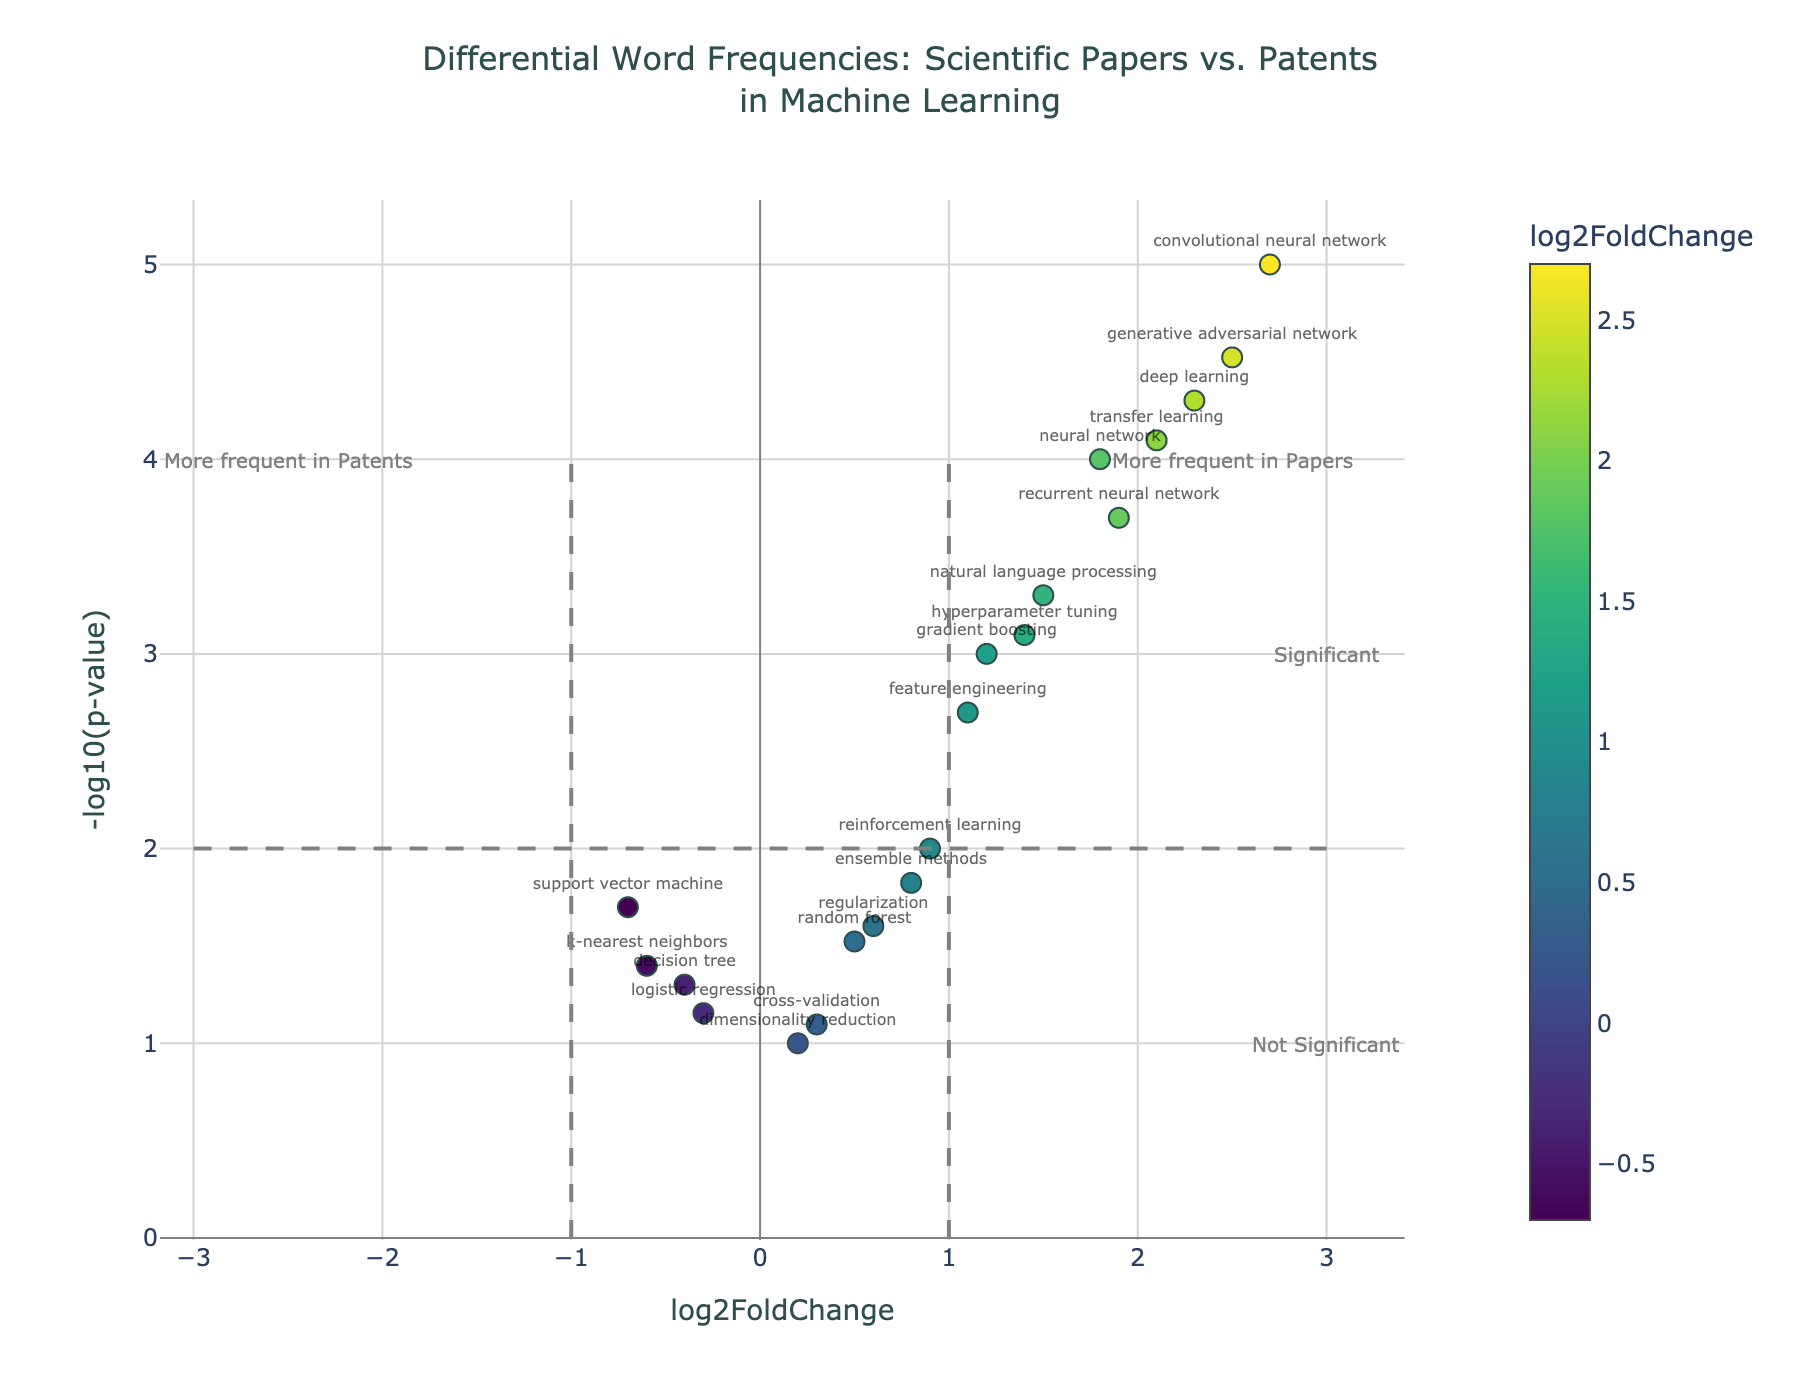what is the title of the figure? The title of the figure is prominently placed at the top and reads: "Differential Word Frequencies: Scientific Papers vs. Patents in Machine Learning"
Answer: Differential Word Frequencies: Scientific Papers vs. Patents in Machine Learning What does the x-axis represent in the volcano plot? The x-axis is labeled "log2FoldChange," indicating it represents the log2 fold change values, which measure the change in frequency of terms between scientific papers and patents.
Answer: log2FoldChange Which term shows the highest log2 fold change? To find the highest log2 fold change, locate the point farthest to the right. "convolutional neural network" achieves the highest value of 2.7.
Answer: convolutional neural network How many terms are considered significant with high frequency in papers? Significant terms in papers have a positive log2 fold change and a -log10(p-value) above the threshold at y=2. Locate these markers in the upper right section. There are seven significant terms: "neural network," "deep learning," "convolutional neural network," "recurrent neural network," "natural language processing," "transfer learning," and "generative adversarial network."
Answer: 7 Which terms are more frequent in patents? Terms more frequent in patents are those with a negative log2 fold change. Locate markers with negative x-values. These terms include "support vector machine," "decision tree," "k-nearest neighbors," and "logistic regression."
Answer: support vector machine, decision tree, k-nearest neighbors, logistic regression What is the approximate -log10(p-value) for "neural network"? Find the "neural network" point and check its y-axis position. Its approximate -log10(p-value) value is marked around 4.
Answer: ~4 Which term has the lowest significance in the plot? Low significance corresponds to terms with small -log10(p-value) values, close to the x-axis. "dimensionality reduction" and "cross-validation," with y-values close to zero, are the least significant terms.
Answer: dimensionality reduction, cross-validation Is "random forest" considered significant in the analysis? A term is considered significant if it surpasses the -log10(p-value) threshold of 2. The point for "random forest" falls below y=2, indicating it is not significant.
Answer: No Which term's frequency is almost equally distributed between papers and patents? The term close to the y-axis at x=0 shows near-equal distribution. "regularization" is positioned close to x=0.
Answer: regularization How many terms are there with a log2 fold change above 2 and significant p-values? Examine points with log2 fold change >2 and -log10(p-value) >2. Four terms fit: "deep learning," "convolutional neural network," "transfer learning," and "generative adversarial network."
Answer: 4 